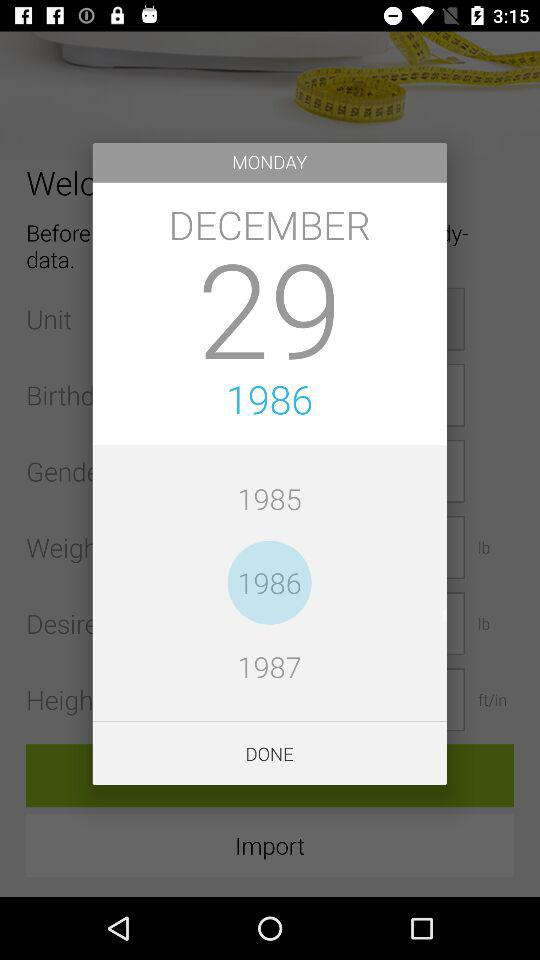How many years are there between the oldest and newest dates?
Answer the question using a single word or phrase. 2 